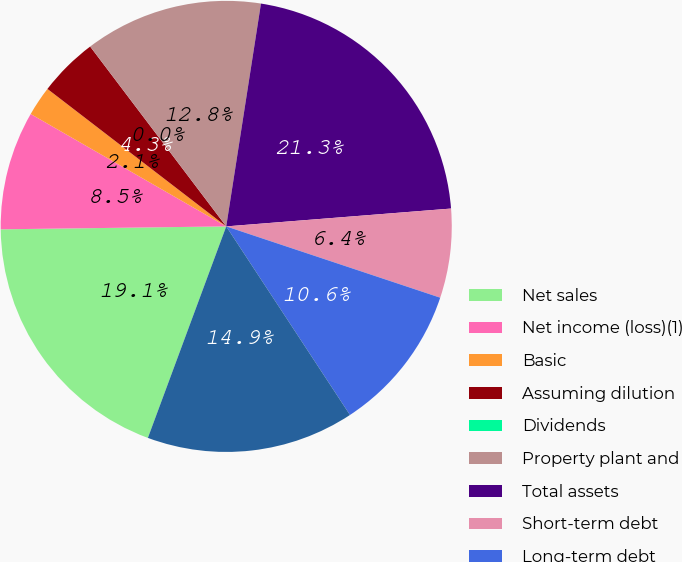Convert chart. <chart><loc_0><loc_0><loc_500><loc_500><pie_chart><fcel>Net sales<fcel>Net income (loss)(1)<fcel>Basic<fcel>Assuming dilution<fcel>Dividends<fcel>Property plant and<fcel>Total assets<fcel>Short-term debt<fcel>Long-term debt<fcel>Total debt<nl><fcel>19.15%<fcel>8.51%<fcel>2.13%<fcel>4.26%<fcel>0.0%<fcel>12.77%<fcel>21.28%<fcel>6.38%<fcel>10.64%<fcel>14.89%<nl></chart> 